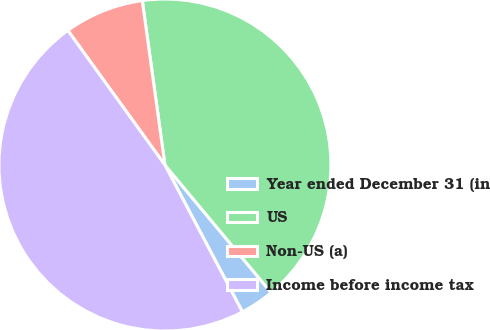Convert chart to OTSL. <chart><loc_0><loc_0><loc_500><loc_500><pie_chart><fcel>Year ended December 31 (in<fcel>US<fcel>Non-US (a)<fcel>Income before income tax<nl><fcel>3.32%<fcel>41.13%<fcel>7.77%<fcel>47.78%<nl></chart> 